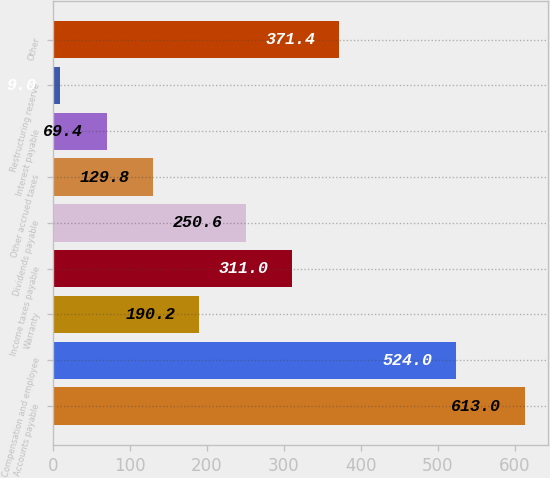<chart> <loc_0><loc_0><loc_500><loc_500><bar_chart><fcel>Accounts payable<fcel>Compensation and employee<fcel>Warranty<fcel>Income taxes payable<fcel>Dividends payable<fcel>Other accrued taxes<fcel>Interest payable<fcel>Restructuring reserve<fcel>Other<nl><fcel>613<fcel>524<fcel>190.2<fcel>311<fcel>250.6<fcel>129.8<fcel>69.4<fcel>9<fcel>371.4<nl></chart> 